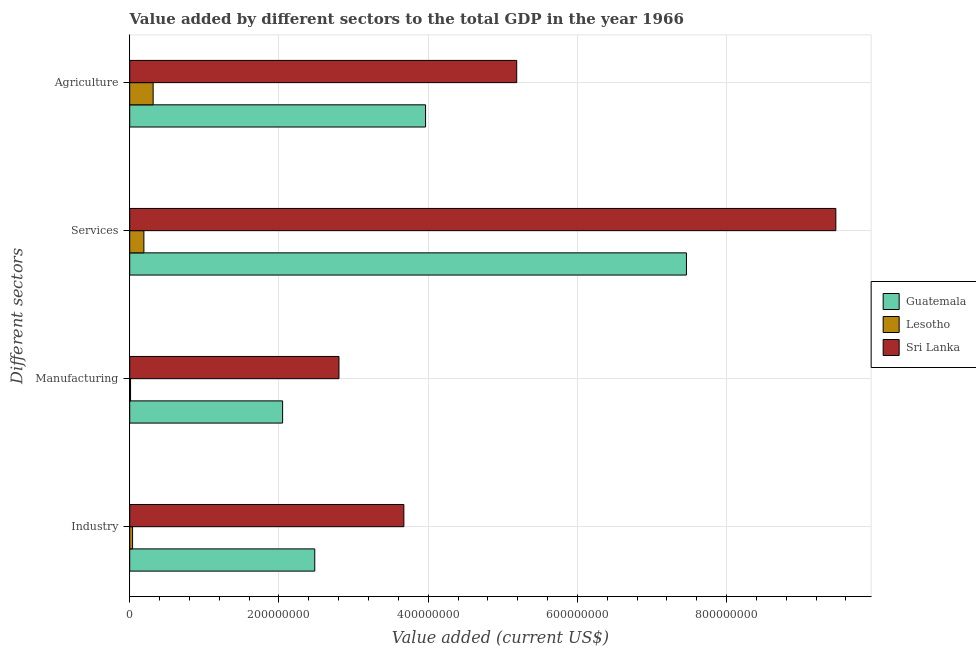How many different coloured bars are there?
Your answer should be compact. 3. How many bars are there on the 2nd tick from the bottom?
Ensure brevity in your answer.  3. What is the label of the 3rd group of bars from the top?
Provide a succinct answer. Manufacturing. What is the value added by industrial sector in Lesotho?
Your response must be concise. 3.81e+06. Across all countries, what is the maximum value added by agricultural sector?
Make the answer very short. 5.19e+08. Across all countries, what is the minimum value added by industrial sector?
Your response must be concise. 3.81e+06. In which country was the value added by agricultural sector maximum?
Keep it short and to the point. Sri Lanka. In which country was the value added by industrial sector minimum?
Keep it short and to the point. Lesotho. What is the total value added by agricultural sector in the graph?
Offer a very short reply. 9.47e+08. What is the difference between the value added by industrial sector in Sri Lanka and that in Lesotho?
Provide a succinct answer. 3.64e+08. What is the difference between the value added by agricultural sector in Guatemala and the value added by manufacturing sector in Sri Lanka?
Make the answer very short. 1.16e+08. What is the average value added by industrial sector per country?
Give a very brief answer. 2.06e+08. What is the difference between the value added by services sector and value added by manufacturing sector in Lesotho?
Your answer should be very brief. 1.79e+07. In how many countries, is the value added by services sector greater than 600000000 US$?
Provide a short and direct response. 2. What is the ratio of the value added by services sector in Lesotho to that in Guatemala?
Offer a terse response. 0.03. What is the difference between the highest and the second highest value added by industrial sector?
Offer a terse response. 1.19e+08. What is the difference between the highest and the lowest value added by manufacturing sector?
Offer a very short reply. 2.79e+08. In how many countries, is the value added by industrial sector greater than the average value added by industrial sector taken over all countries?
Ensure brevity in your answer.  2. Is it the case that in every country, the sum of the value added by services sector and value added by agricultural sector is greater than the sum of value added by industrial sector and value added by manufacturing sector?
Ensure brevity in your answer.  No. What does the 1st bar from the top in Agriculture represents?
Offer a very short reply. Sri Lanka. What does the 3rd bar from the bottom in Services represents?
Keep it short and to the point. Sri Lanka. What is the difference between two consecutive major ticks on the X-axis?
Your response must be concise. 2.00e+08. Does the graph contain any zero values?
Your answer should be very brief. No. Where does the legend appear in the graph?
Provide a succinct answer. Center right. How many legend labels are there?
Ensure brevity in your answer.  3. What is the title of the graph?
Your response must be concise. Value added by different sectors to the total GDP in the year 1966. Does "Benin" appear as one of the legend labels in the graph?
Provide a succinct answer. No. What is the label or title of the X-axis?
Your answer should be compact. Value added (current US$). What is the label or title of the Y-axis?
Give a very brief answer. Different sectors. What is the Value added (current US$) in Guatemala in Industry?
Provide a succinct answer. 2.48e+08. What is the Value added (current US$) of Lesotho in Industry?
Keep it short and to the point. 3.81e+06. What is the Value added (current US$) in Sri Lanka in Industry?
Provide a short and direct response. 3.67e+08. What is the Value added (current US$) of Guatemala in Manufacturing?
Keep it short and to the point. 2.05e+08. What is the Value added (current US$) in Lesotho in Manufacturing?
Make the answer very short. 1.12e+06. What is the Value added (current US$) of Sri Lanka in Manufacturing?
Make the answer very short. 2.80e+08. What is the Value added (current US$) of Guatemala in Services?
Provide a short and direct response. 7.46e+08. What is the Value added (current US$) in Lesotho in Services?
Your response must be concise. 1.90e+07. What is the Value added (current US$) in Sri Lanka in Services?
Offer a terse response. 9.46e+08. What is the Value added (current US$) in Guatemala in Agriculture?
Keep it short and to the point. 3.97e+08. What is the Value added (current US$) in Lesotho in Agriculture?
Offer a terse response. 3.14e+07. What is the Value added (current US$) in Sri Lanka in Agriculture?
Offer a very short reply. 5.19e+08. Across all Different sectors, what is the maximum Value added (current US$) in Guatemala?
Provide a succinct answer. 7.46e+08. Across all Different sectors, what is the maximum Value added (current US$) of Lesotho?
Offer a terse response. 3.14e+07. Across all Different sectors, what is the maximum Value added (current US$) of Sri Lanka?
Your response must be concise. 9.46e+08. Across all Different sectors, what is the minimum Value added (current US$) of Guatemala?
Provide a short and direct response. 2.05e+08. Across all Different sectors, what is the minimum Value added (current US$) in Lesotho?
Your answer should be compact. 1.12e+06. Across all Different sectors, what is the minimum Value added (current US$) of Sri Lanka?
Make the answer very short. 2.80e+08. What is the total Value added (current US$) in Guatemala in the graph?
Your response must be concise. 1.60e+09. What is the total Value added (current US$) in Lesotho in the graph?
Provide a short and direct response. 5.53e+07. What is the total Value added (current US$) in Sri Lanka in the graph?
Keep it short and to the point. 2.11e+09. What is the difference between the Value added (current US$) of Guatemala in Industry and that in Manufacturing?
Offer a very short reply. 4.31e+07. What is the difference between the Value added (current US$) of Lesotho in Industry and that in Manufacturing?
Ensure brevity in your answer.  2.69e+06. What is the difference between the Value added (current US$) in Sri Lanka in Industry and that in Manufacturing?
Keep it short and to the point. 8.70e+07. What is the difference between the Value added (current US$) of Guatemala in Industry and that in Services?
Provide a short and direct response. -4.98e+08. What is the difference between the Value added (current US$) in Lesotho in Industry and that in Services?
Make the answer very short. -1.52e+07. What is the difference between the Value added (current US$) in Sri Lanka in Industry and that in Services?
Offer a very short reply. -5.79e+08. What is the difference between the Value added (current US$) in Guatemala in Industry and that in Agriculture?
Provide a succinct answer. -1.49e+08. What is the difference between the Value added (current US$) in Lesotho in Industry and that in Agriculture?
Offer a very short reply. -2.76e+07. What is the difference between the Value added (current US$) of Sri Lanka in Industry and that in Agriculture?
Ensure brevity in your answer.  -1.51e+08. What is the difference between the Value added (current US$) of Guatemala in Manufacturing and that in Services?
Give a very brief answer. -5.41e+08. What is the difference between the Value added (current US$) of Lesotho in Manufacturing and that in Services?
Your answer should be very brief. -1.79e+07. What is the difference between the Value added (current US$) in Sri Lanka in Manufacturing and that in Services?
Provide a short and direct response. -6.66e+08. What is the difference between the Value added (current US$) in Guatemala in Manufacturing and that in Agriculture?
Give a very brief answer. -1.92e+08. What is the difference between the Value added (current US$) in Lesotho in Manufacturing and that in Agriculture?
Your answer should be very brief. -3.03e+07. What is the difference between the Value added (current US$) of Sri Lanka in Manufacturing and that in Agriculture?
Offer a terse response. -2.38e+08. What is the difference between the Value added (current US$) in Guatemala in Services and that in Agriculture?
Give a very brief answer. 3.50e+08. What is the difference between the Value added (current US$) in Lesotho in Services and that in Agriculture?
Your answer should be compact. -1.24e+07. What is the difference between the Value added (current US$) of Sri Lanka in Services and that in Agriculture?
Your response must be concise. 4.28e+08. What is the difference between the Value added (current US$) of Guatemala in Industry and the Value added (current US$) of Lesotho in Manufacturing?
Your answer should be compact. 2.47e+08. What is the difference between the Value added (current US$) of Guatemala in Industry and the Value added (current US$) of Sri Lanka in Manufacturing?
Give a very brief answer. -3.25e+07. What is the difference between the Value added (current US$) in Lesotho in Industry and the Value added (current US$) in Sri Lanka in Manufacturing?
Keep it short and to the point. -2.77e+08. What is the difference between the Value added (current US$) of Guatemala in Industry and the Value added (current US$) of Lesotho in Services?
Give a very brief answer. 2.29e+08. What is the difference between the Value added (current US$) in Guatemala in Industry and the Value added (current US$) in Sri Lanka in Services?
Provide a succinct answer. -6.98e+08. What is the difference between the Value added (current US$) in Lesotho in Industry and the Value added (current US$) in Sri Lanka in Services?
Ensure brevity in your answer.  -9.43e+08. What is the difference between the Value added (current US$) in Guatemala in Industry and the Value added (current US$) in Lesotho in Agriculture?
Make the answer very short. 2.17e+08. What is the difference between the Value added (current US$) of Guatemala in Industry and the Value added (current US$) of Sri Lanka in Agriculture?
Offer a terse response. -2.71e+08. What is the difference between the Value added (current US$) in Lesotho in Industry and the Value added (current US$) in Sri Lanka in Agriculture?
Your response must be concise. -5.15e+08. What is the difference between the Value added (current US$) of Guatemala in Manufacturing and the Value added (current US$) of Lesotho in Services?
Give a very brief answer. 1.86e+08. What is the difference between the Value added (current US$) in Guatemala in Manufacturing and the Value added (current US$) in Sri Lanka in Services?
Give a very brief answer. -7.42e+08. What is the difference between the Value added (current US$) in Lesotho in Manufacturing and the Value added (current US$) in Sri Lanka in Services?
Offer a terse response. -9.45e+08. What is the difference between the Value added (current US$) in Guatemala in Manufacturing and the Value added (current US$) in Lesotho in Agriculture?
Keep it short and to the point. 1.74e+08. What is the difference between the Value added (current US$) of Guatemala in Manufacturing and the Value added (current US$) of Sri Lanka in Agriculture?
Ensure brevity in your answer.  -3.14e+08. What is the difference between the Value added (current US$) in Lesotho in Manufacturing and the Value added (current US$) in Sri Lanka in Agriculture?
Offer a very short reply. -5.18e+08. What is the difference between the Value added (current US$) of Guatemala in Services and the Value added (current US$) of Lesotho in Agriculture?
Provide a succinct answer. 7.15e+08. What is the difference between the Value added (current US$) of Guatemala in Services and the Value added (current US$) of Sri Lanka in Agriculture?
Offer a terse response. 2.27e+08. What is the difference between the Value added (current US$) of Lesotho in Services and the Value added (current US$) of Sri Lanka in Agriculture?
Give a very brief answer. -5.00e+08. What is the average Value added (current US$) in Guatemala per Different sectors?
Provide a succinct answer. 3.99e+08. What is the average Value added (current US$) of Lesotho per Different sectors?
Keep it short and to the point. 1.38e+07. What is the average Value added (current US$) of Sri Lanka per Different sectors?
Your answer should be very brief. 5.28e+08. What is the difference between the Value added (current US$) in Guatemala and Value added (current US$) in Lesotho in Industry?
Provide a succinct answer. 2.44e+08. What is the difference between the Value added (current US$) of Guatemala and Value added (current US$) of Sri Lanka in Industry?
Provide a succinct answer. -1.19e+08. What is the difference between the Value added (current US$) of Lesotho and Value added (current US$) of Sri Lanka in Industry?
Provide a short and direct response. -3.64e+08. What is the difference between the Value added (current US$) in Guatemala and Value added (current US$) in Lesotho in Manufacturing?
Keep it short and to the point. 2.04e+08. What is the difference between the Value added (current US$) in Guatemala and Value added (current US$) in Sri Lanka in Manufacturing?
Your answer should be very brief. -7.55e+07. What is the difference between the Value added (current US$) of Lesotho and Value added (current US$) of Sri Lanka in Manufacturing?
Offer a very short reply. -2.79e+08. What is the difference between the Value added (current US$) of Guatemala and Value added (current US$) of Lesotho in Services?
Ensure brevity in your answer.  7.27e+08. What is the difference between the Value added (current US$) of Guatemala and Value added (current US$) of Sri Lanka in Services?
Give a very brief answer. -2.00e+08. What is the difference between the Value added (current US$) in Lesotho and Value added (current US$) in Sri Lanka in Services?
Your answer should be compact. -9.27e+08. What is the difference between the Value added (current US$) in Guatemala and Value added (current US$) in Lesotho in Agriculture?
Your answer should be compact. 3.65e+08. What is the difference between the Value added (current US$) of Guatemala and Value added (current US$) of Sri Lanka in Agriculture?
Offer a very short reply. -1.22e+08. What is the difference between the Value added (current US$) of Lesotho and Value added (current US$) of Sri Lanka in Agriculture?
Your response must be concise. -4.87e+08. What is the ratio of the Value added (current US$) of Guatemala in Industry to that in Manufacturing?
Your answer should be compact. 1.21. What is the ratio of the Value added (current US$) in Lesotho in Industry to that in Manufacturing?
Your response must be concise. 3.41. What is the ratio of the Value added (current US$) of Sri Lanka in Industry to that in Manufacturing?
Make the answer very short. 1.31. What is the ratio of the Value added (current US$) of Guatemala in Industry to that in Services?
Offer a very short reply. 0.33. What is the ratio of the Value added (current US$) in Lesotho in Industry to that in Services?
Your answer should be compact. 0.2. What is the ratio of the Value added (current US$) in Sri Lanka in Industry to that in Services?
Offer a very short reply. 0.39. What is the ratio of the Value added (current US$) in Guatemala in Industry to that in Agriculture?
Offer a terse response. 0.63. What is the ratio of the Value added (current US$) in Lesotho in Industry to that in Agriculture?
Give a very brief answer. 0.12. What is the ratio of the Value added (current US$) in Sri Lanka in Industry to that in Agriculture?
Keep it short and to the point. 0.71. What is the ratio of the Value added (current US$) in Guatemala in Manufacturing to that in Services?
Make the answer very short. 0.27. What is the ratio of the Value added (current US$) of Lesotho in Manufacturing to that in Services?
Offer a very short reply. 0.06. What is the ratio of the Value added (current US$) of Sri Lanka in Manufacturing to that in Services?
Offer a terse response. 0.3. What is the ratio of the Value added (current US$) in Guatemala in Manufacturing to that in Agriculture?
Keep it short and to the point. 0.52. What is the ratio of the Value added (current US$) in Lesotho in Manufacturing to that in Agriculture?
Offer a terse response. 0.04. What is the ratio of the Value added (current US$) of Sri Lanka in Manufacturing to that in Agriculture?
Give a very brief answer. 0.54. What is the ratio of the Value added (current US$) in Guatemala in Services to that in Agriculture?
Provide a short and direct response. 1.88. What is the ratio of the Value added (current US$) in Lesotho in Services to that in Agriculture?
Offer a very short reply. 0.6. What is the ratio of the Value added (current US$) of Sri Lanka in Services to that in Agriculture?
Keep it short and to the point. 1.82. What is the difference between the highest and the second highest Value added (current US$) in Guatemala?
Provide a short and direct response. 3.50e+08. What is the difference between the highest and the second highest Value added (current US$) in Lesotho?
Your answer should be compact. 1.24e+07. What is the difference between the highest and the second highest Value added (current US$) in Sri Lanka?
Ensure brevity in your answer.  4.28e+08. What is the difference between the highest and the lowest Value added (current US$) in Guatemala?
Provide a succinct answer. 5.41e+08. What is the difference between the highest and the lowest Value added (current US$) of Lesotho?
Offer a terse response. 3.03e+07. What is the difference between the highest and the lowest Value added (current US$) of Sri Lanka?
Keep it short and to the point. 6.66e+08. 